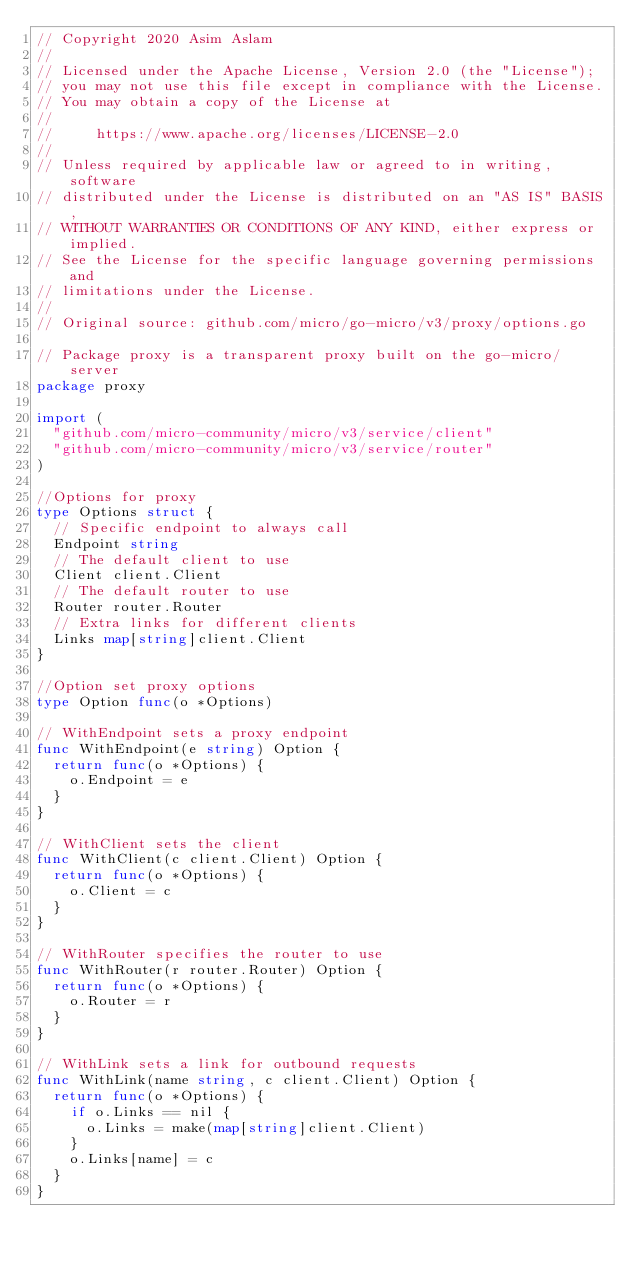<code> <loc_0><loc_0><loc_500><loc_500><_Go_>// Copyright 2020 Asim Aslam
//
// Licensed under the Apache License, Version 2.0 (the "License");
// you may not use this file except in compliance with the License.
// You may obtain a copy of the License at
//
//     https://www.apache.org/licenses/LICENSE-2.0
//
// Unless required by applicable law or agreed to in writing, software
// distributed under the License is distributed on an "AS IS" BASIS,
// WITHOUT WARRANTIES OR CONDITIONS OF ANY KIND, either express or implied.
// See the License for the specific language governing permissions and
// limitations under the License.
//
// Original source: github.com/micro/go-micro/v3/proxy/options.go

// Package proxy is a transparent proxy built on the go-micro/server
package proxy

import (
	"github.com/micro-community/micro/v3/service/client"
	"github.com/micro-community/micro/v3/service/router"
)

//Options for proxy
type Options struct {
	// Specific endpoint to always call
	Endpoint string
	// The default client to use
	Client client.Client
	// The default router to use
	Router router.Router
	// Extra links for different clients
	Links map[string]client.Client
}

//Option set proxy options
type Option func(o *Options)

// WithEndpoint sets a proxy endpoint
func WithEndpoint(e string) Option {
	return func(o *Options) {
		o.Endpoint = e
	}
}

// WithClient sets the client
func WithClient(c client.Client) Option {
	return func(o *Options) {
		o.Client = c
	}
}

// WithRouter specifies the router to use
func WithRouter(r router.Router) Option {
	return func(o *Options) {
		o.Router = r
	}
}

// WithLink sets a link for outbound requests
func WithLink(name string, c client.Client) Option {
	return func(o *Options) {
		if o.Links == nil {
			o.Links = make(map[string]client.Client)
		}
		o.Links[name] = c
	}
}
</code> 